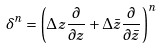Convert formula to latex. <formula><loc_0><loc_0><loc_500><loc_500>\delta ^ { n } = \left ( \Delta z \frac { \partial } { \partial z } + \Delta \bar { z } \frac { \partial } { \partial \bar { z } } \right ) ^ { n }</formula> 